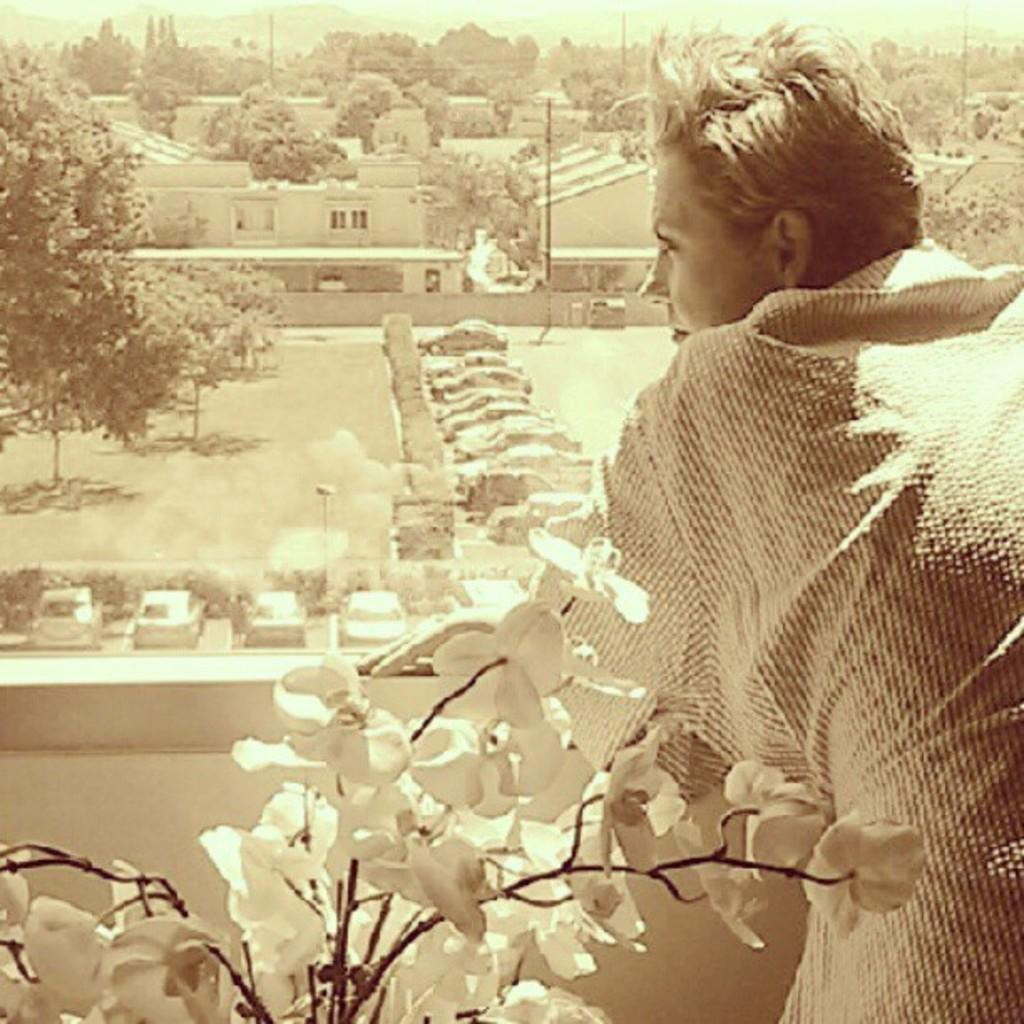What is located on the right side of the image? There is a person standing on the right side of the image. What is in the center of the image? There is a plant in the center of the image. What can be seen in the background of the image? Cars, trees, buildings, poles, and the sky are visible in the background of the image. How many loaves of bread are on the bookshelf in the image? There is no bookshelf or loaves of bread present in the image. What type of curtain is hanging in the background of the image? There is no curtain visible in the background of the image; only cars, trees, buildings, poles, and the sky are present. 